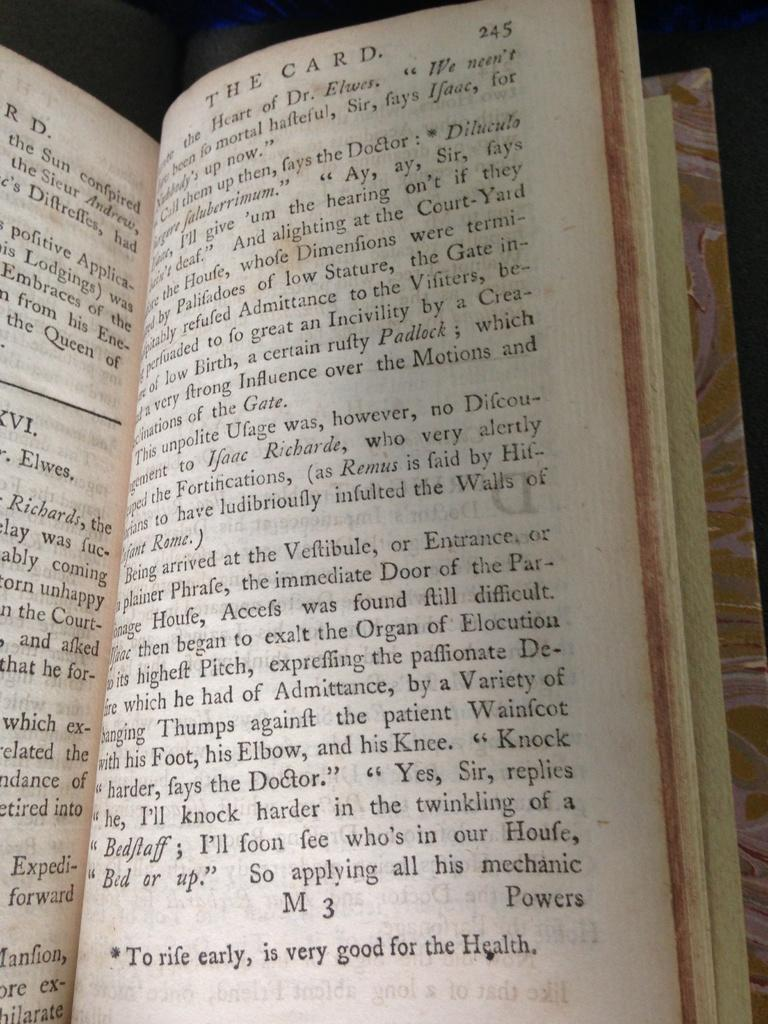<image>
Write a terse but informative summary of the picture. A book with the chapter titled The Card. 